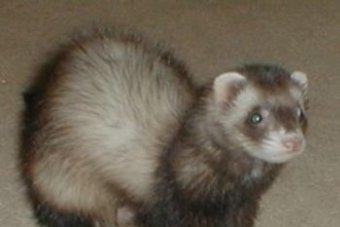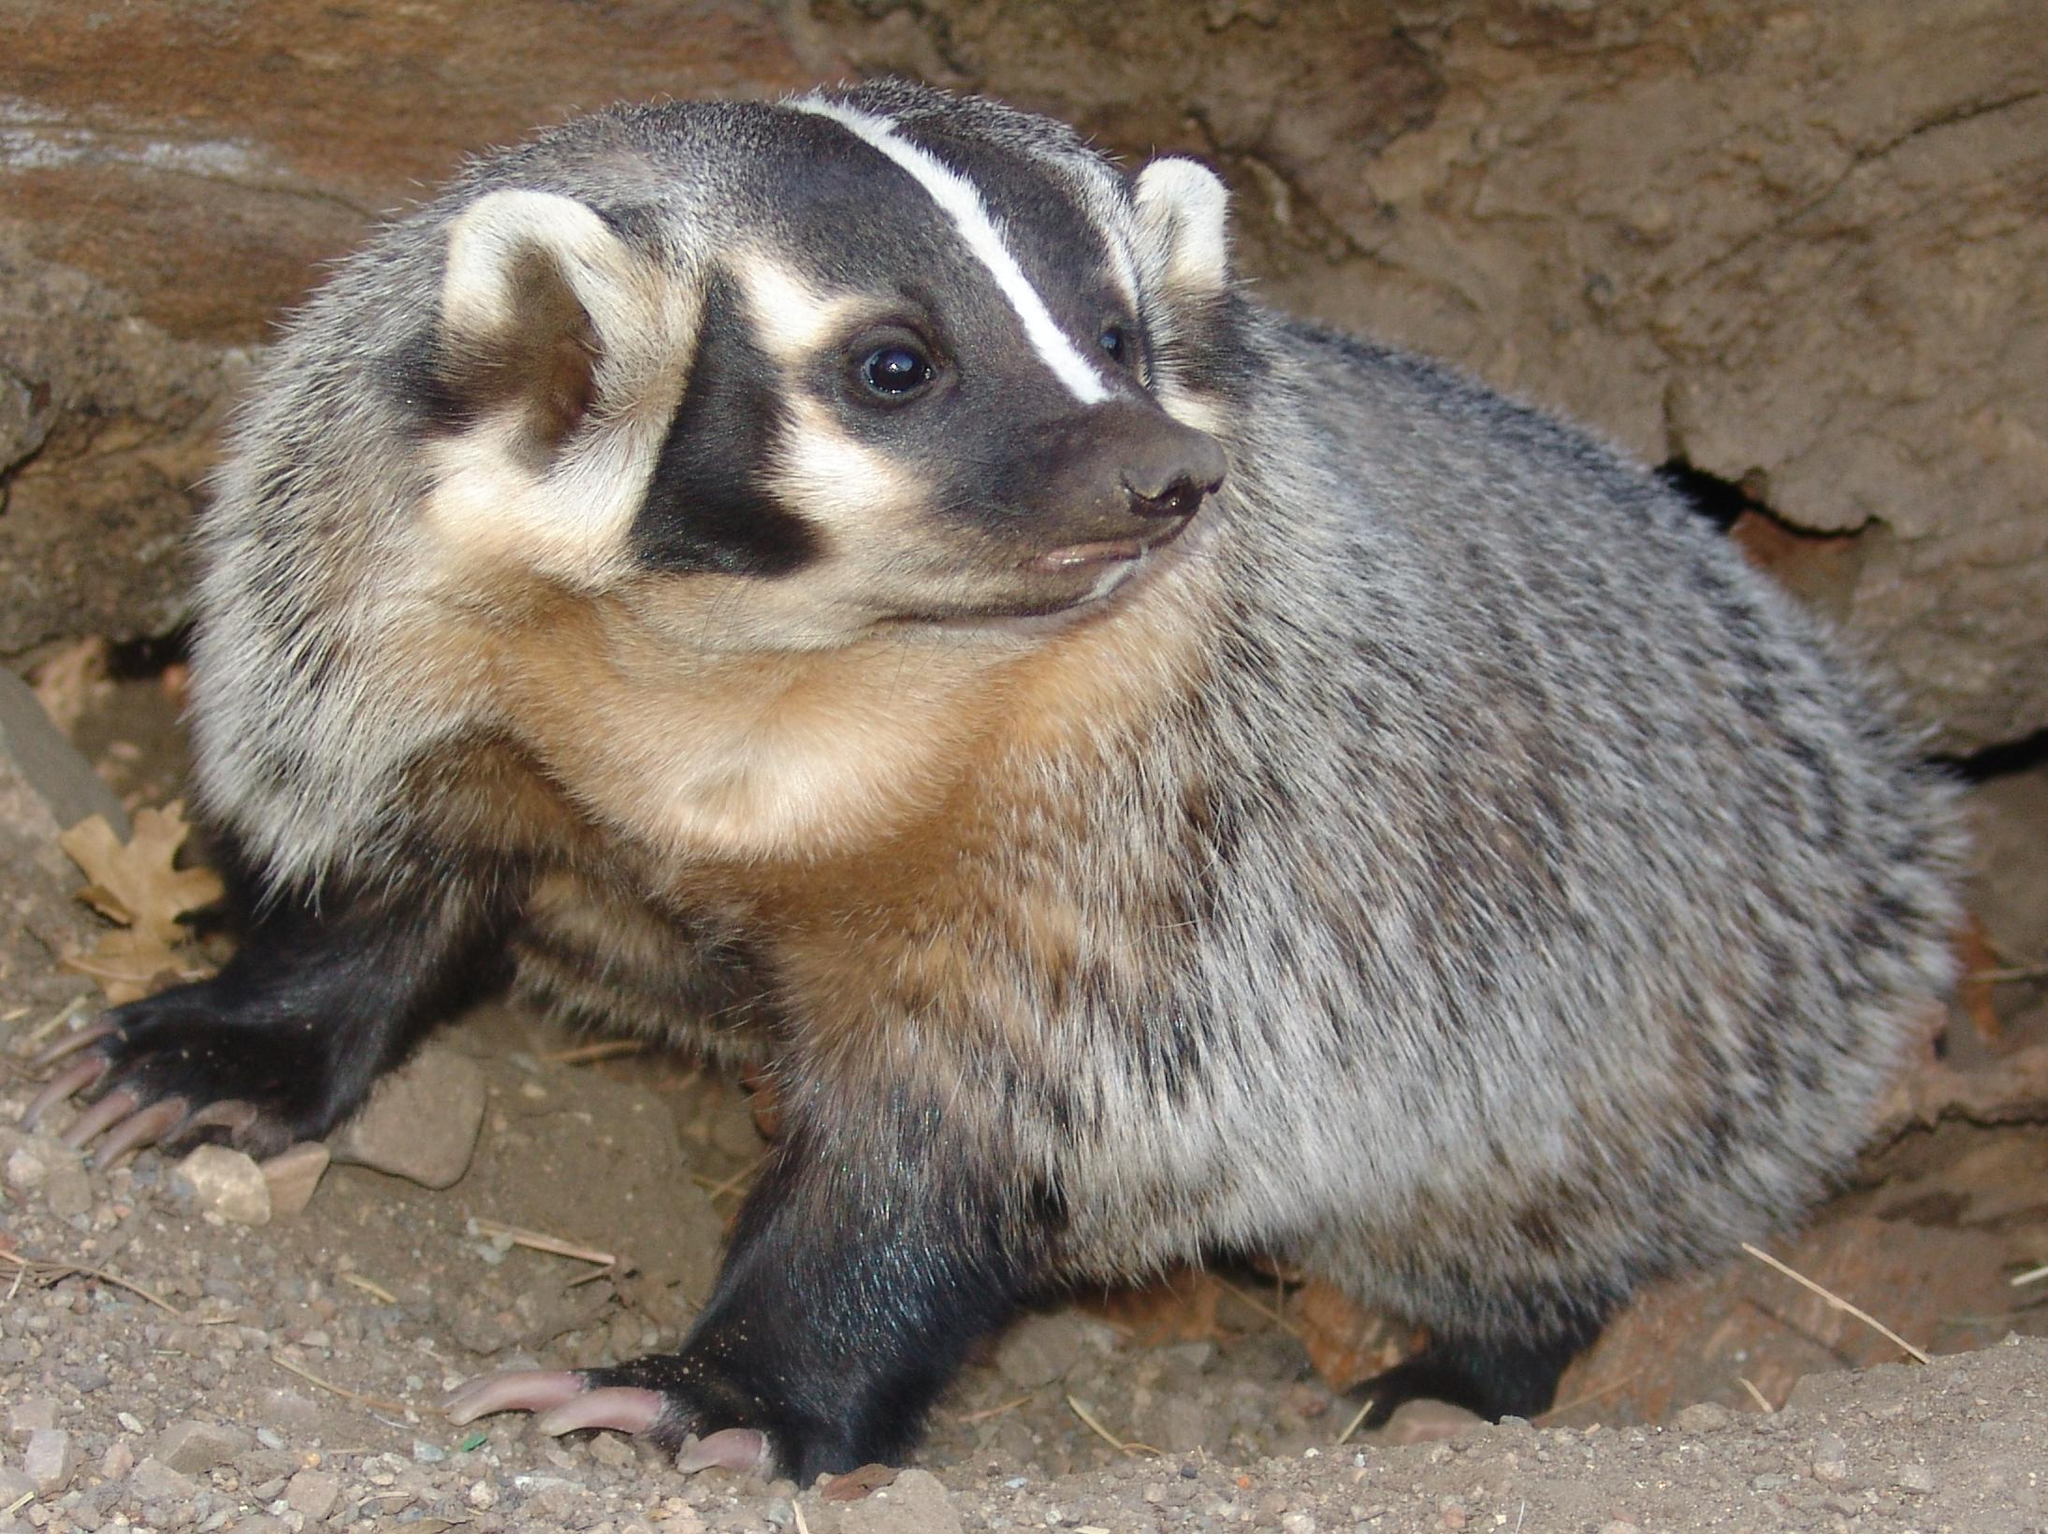The first image is the image on the left, the second image is the image on the right. Analyze the images presented: Is the assertion "The combined images contain five ferrets, and at least three are peering up from a low spot." valid? Answer yes or no. No. The first image is the image on the left, the second image is the image on the right. Considering the images on both sides, is "An image shows one ferret standing with its tail outstretched behind it, while a second image shows three or more ferrets." valid? Answer yes or no. No. 